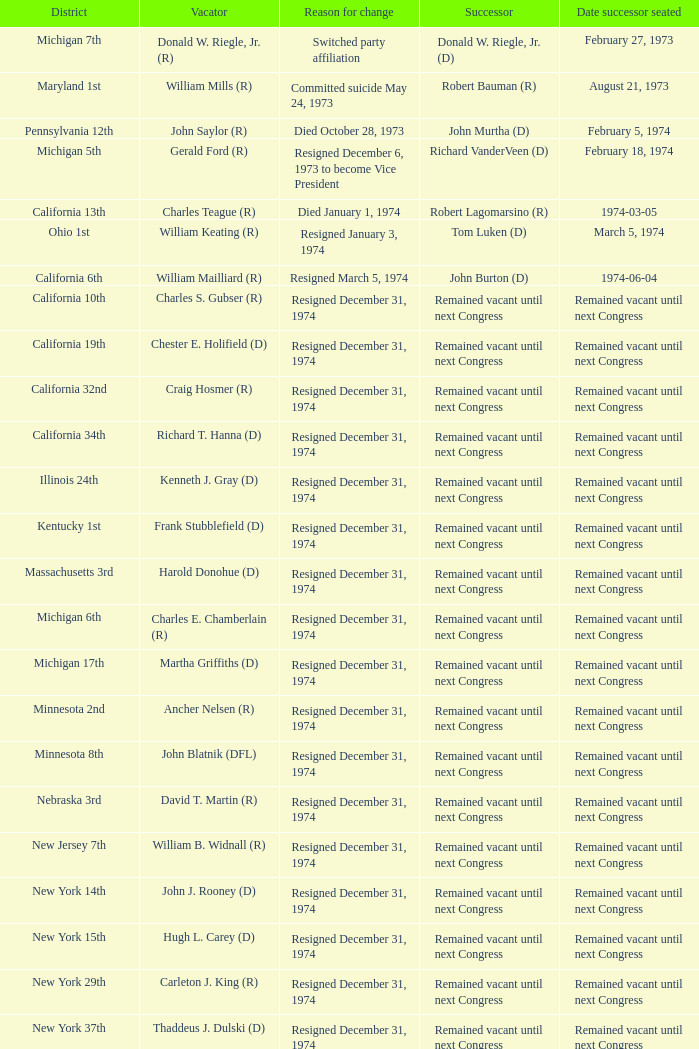Who was the successor when the position was vacated by chester e. holifield (d)? Remained vacant until next Congress. 